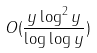<formula> <loc_0><loc_0><loc_500><loc_500>O ( \frac { y \log ^ { 2 } y } { \log \log y } )</formula> 